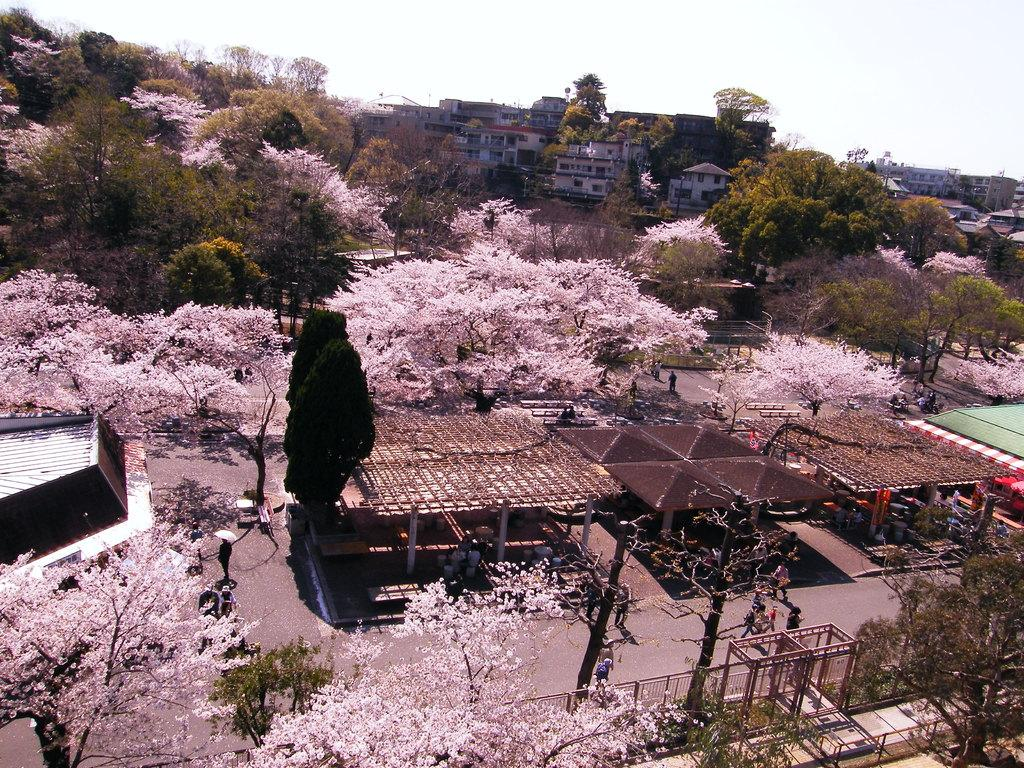What type of natural elements can be seen in the image? There are trees in the image. Are there any human figures present in the image? Yes, there are people in the image. What type of structures can be seen in the image? There are sheds and buildings in the image. What is the purpose of the fence at the bottom of the image? The fence at the bottom of the image may serve as a boundary or barrier. What is visible at the top of the image? The sky is visible at the top of the image. Can you tell me how many shoes are hanging from the trees in the image? There are no shoes hanging from the trees in the image; only trees, people, sheds, buildings, a fence, and the sky are present. What type of fowl can be seen interacting with the people in the image? There is no fowl present in the image; only trees, people, sheds, buildings, a fence, and the sky are visible. 